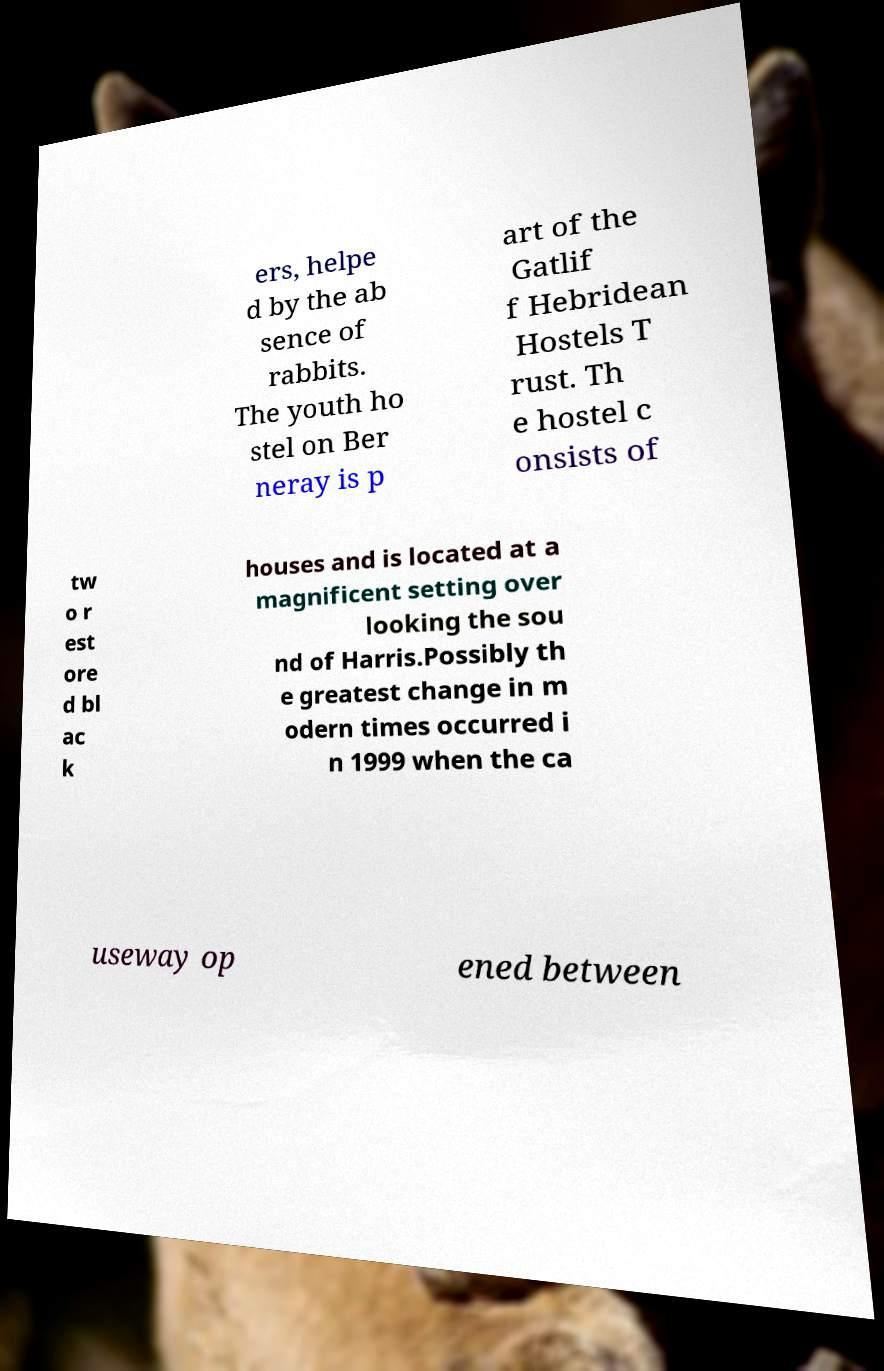What messages or text are displayed in this image? I need them in a readable, typed format. ers, helpe d by the ab sence of rabbits. The youth ho stel on Ber neray is p art of the Gatlif f Hebridean Hostels T rust. Th e hostel c onsists of tw o r est ore d bl ac k houses and is located at a magnificent setting over looking the sou nd of Harris.Possibly th e greatest change in m odern times occurred i n 1999 when the ca useway op ened between 